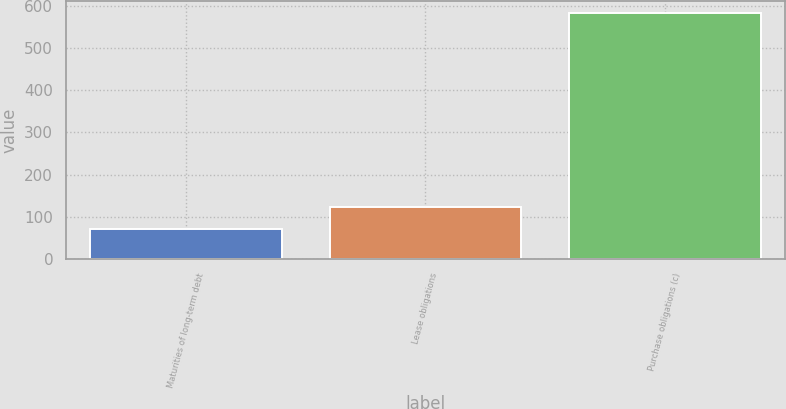Convert chart. <chart><loc_0><loc_0><loc_500><loc_500><bar_chart><fcel>Maturities of long-term debt<fcel>Lease obligations<fcel>Purchase obligations (c)<nl><fcel>71<fcel>122.2<fcel>583<nl></chart> 